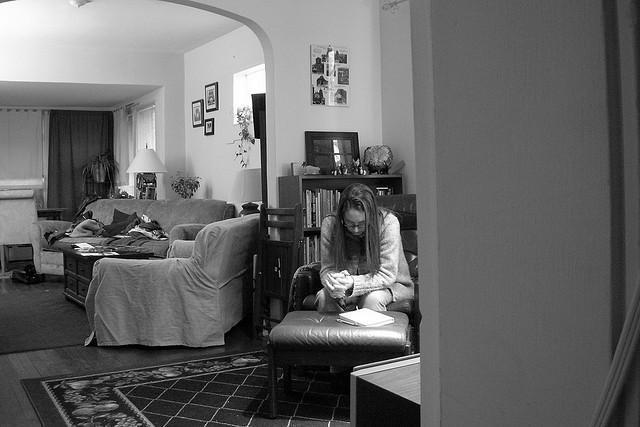How many couches are there?
Give a very brief answer. 2. How many chairs are in the picture?
Give a very brief answer. 2. 